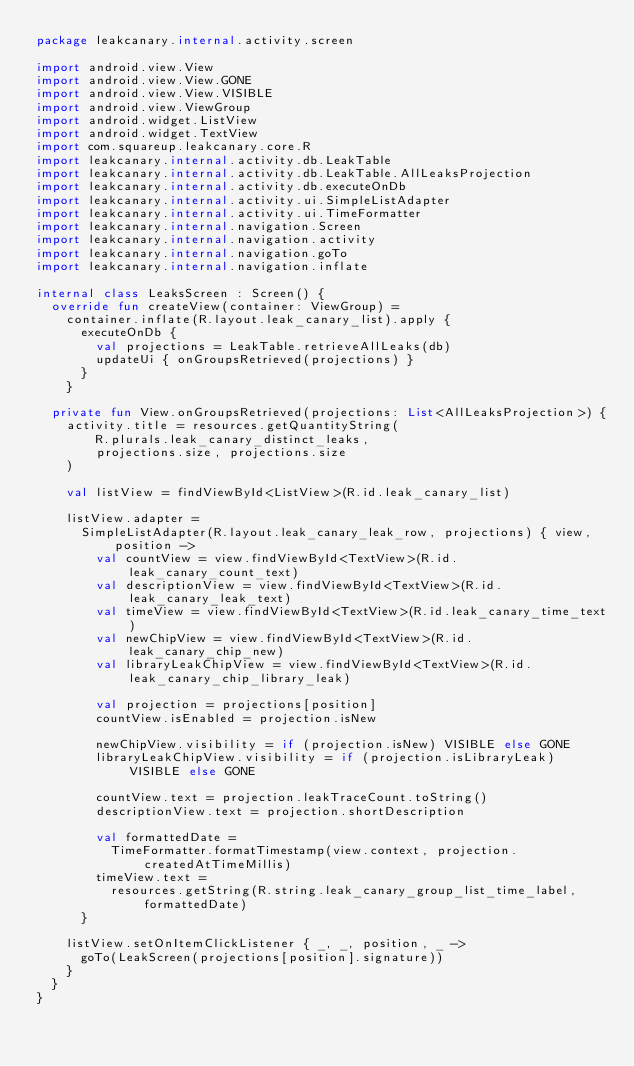Convert code to text. <code><loc_0><loc_0><loc_500><loc_500><_Kotlin_>package leakcanary.internal.activity.screen

import android.view.View
import android.view.View.GONE
import android.view.View.VISIBLE
import android.view.ViewGroup
import android.widget.ListView
import android.widget.TextView
import com.squareup.leakcanary.core.R
import leakcanary.internal.activity.db.LeakTable
import leakcanary.internal.activity.db.LeakTable.AllLeaksProjection
import leakcanary.internal.activity.db.executeOnDb
import leakcanary.internal.activity.ui.SimpleListAdapter
import leakcanary.internal.activity.ui.TimeFormatter
import leakcanary.internal.navigation.Screen
import leakcanary.internal.navigation.activity
import leakcanary.internal.navigation.goTo
import leakcanary.internal.navigation.inflate

internal class LeaksScreen : Screen() {
  override fun createView(container: ViewGroup) =
    container.inflate(R.layout.leak_canary_list).apply {
      executeOnDb {
        val projections = LeakTable.retrieveAllLeaks(db)
        updateUi { onGroupsRetrieved(projections) }
      }
    }

  private fun View.onGroupsRetrieved(projections: List<AllLeaksProjection>) {
    activity.title = resources.getQuantityString(
        R.plurals.leak_canary_distinct_leaks,
        projections.size, projections.size
    )

    val listView = findViewById<ListView>(R.id.leak_canary_list)

    listView.adapter =
      SimpleListAdapter(R.layout.leak_canary_leak_row, projections) { view, position ->
        val countView = view.findViewById<TextView>(R.id.leak_canary_count_text)
        val descriptionView = view.findViewById<TextView>(R.id.leak_canary_leak_text)
        val timeView = view.findViewById<TextView>(R.id.leak_canary_time_text)
        val newChipView = view.findViewById<TextView>(R.id.leak_canary_chip_new)
        val libraryLeakChipView = view.findViewById<TextView>(R.id.leak_canary_chip_library_leak)

        val projection = projections[position]
        countView.isEnabled = projection.isNew

        newChipView.visibility = if (projection.isNew) VISIBLE else GONE
        libraryLeakChipView.visibility = if (projection.isLibraryLeak) VISIBLE else GONE

        countView.text = projection.leakTraceCount.toString()
        descriptionView.text = projection.shortDescription

        val formattedDate =
          TimeFormatter.formatTimestamp(view.context, projection.createdAtTimeMillis)
        timeView.text =
          resources.getString(R.string.leak_canary_group_list_time_label, formattedDate)
      }

    listView.setOnItemClickListener { _, _, position, _ ->
      goTo(LeakScreen(projections[position].signature))
    }
  }
}</code> 